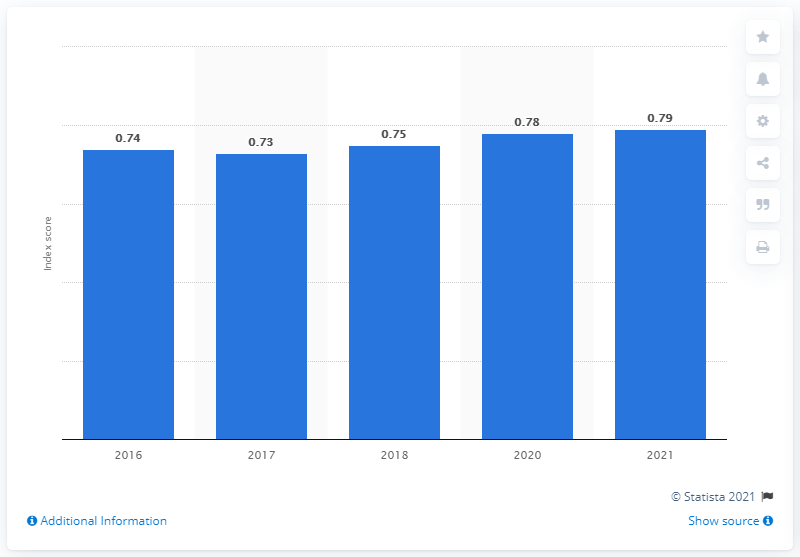Specify some key components in this picture. The gender gap score in 2017 was 0.73. In the year 2021, Costa Rica scored 0.786 on the gender gap index. 